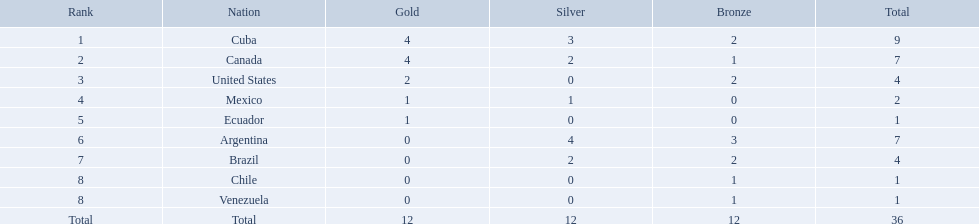What countries participated? Cuba, 4, 3, 2, Canada, 4, 2, 1, United States, 2, 0, 2, Mexico, 1, 1, 0, Ecuador, 1, 0, 0, Argentina, 0, 4, 3, Brazil, 0, 2, 2, Chile, 0, 0, 1, Venezuela, 0, 0, 1. What countries won 1 gold Mexico, 1, 1, 0, Ecuador, 1, 0, 0. What country above also won no silver? Ecuador. Which countries won medals at the 2011 pan american games for the canoeing event? Cuba, Canada, United States, Mexico, Ecuador, Argentina, Brazil, Chile, Venezuela. Which of these countries won bronze medals? Cuba, Canada, United States, Argentina, Brazil, Chile, Venezuela. Of these countries, which won the most bronze medals? Argentina. What were all of the countries participating in canoeing at the 2011 pan american games? Cuba, Canada, United States, Mexico, Ecuador, Argentina, Brazil, Chile, Venezuela, Total. Among them, which had a numerical ranking? Cuba, Canada, United States, Mexico, Ecuador, Argentina, Brazil, Chile, Venezuela. From those, which had the most bronze medals? Argentina. Which nations have secured gold medals? Cuba, Canada, United States, Mexico, Ecuador. Of these nations, which ones have never achieved silver or bronze medals? United States, Ecuador. Of the two countries mentioned earlier, which one has solely won a gold medal? Ecuador. Which nations have garnered gold medals? Cuba, Canada, United States, Mexico, Ecuador. Of these nations, which ones have never earned silver or bronze medals? United States, Ecuador. Of the two countries mentioned before, which one has only won a gold medal? Ecuador. Which national teams earned gold medals? Cuba, Canada, United States, Mexico, Ecuador. How many medals did each national team collect? Cuba, 9, Canada, 7, United States, 4, Mexico, 2, Ecuador, 1. Which national team only captured a gold medal? Ecuador. What nations were involved? Cuba, Canada, United States, Mexico, Ecuador, Argentina, Brazil, Chile, Venezuela. What nations claimed gold? Cuba, Canada, United States, Mexico, Ecuador. What nations failed to get silver? United States, Ecuador, Chile, Venezuela. Among the stated countries, which nation won gold? United States. Can you give me this table as a dict? {'header': ['Rank', 'Nation', 'Gold', 'Silver', 'Bronze', 'Total'], 'rows': [['1', 'Cuba', '4', '3', '2', '9'], ['2', 'Canada', '4', '2', '1', '7'], ['3', 'United States', '2', '0', '2', '4'], ['4', 'Mexico', '1', '1', '0', '2'], ['5', 'Ecuador', '1', '0', '0', '1'], ['6', 'Argentina', '0', '4', '3', '7'], ['7', 'Brazil', '0', '2', '2', '4'], ['8', 'Chile', '0', '0', '1', '1'], ['8', 'Venezuela', '0', '0', '1', '1'], ['Total', 'Total', '12', '12', '12', '36']]} What were the counts of bronze medals gained by the countries? 2, 1, 2, 0, 0, 3, 2, 1, 1. Which is the maximum? 3. Which nation had this total? Argentina. In which nations have gold medals been awarded? Cuba, Canada, United States, Mexico, Ecuador. Among them, which have not received silver or bronze medals? United States, Ecuador. Out of the previously mentioned countries, which one has exclusively achieved a gold medal? Ecuador. In which countries have gold medals been secured? Cuba, Canada, United States, Mexico, Ecuador. From these nations, which ones have never achieved silver or bronze medals? United States, Ecuador. Of the two countries mentioned earlier, which one has only claimed a gold medal? Ecuador. Would you mind parsing the complete table? {'header': ['Rank', 'Nation', 'Gold', 'Silver', 'Bronze', 'Total'], 'rows': [['1', 'Cuba', '4', '3', '2', '9'], ['2', 'Canada', '4', '2', '1', '7'], ['3', 'United States', '2', '0', '2', '4'], ['4', 'Mexico', '1', '1', '0', '2'], ['5', 'Ecuador', '1', '0', '0', '1'], ['6', 'Argentina', '0', '4', '3', '7'], ['7', 'Brazil', '0', '2', '2', '4'], ['8', 'Chile', '0', '0', '1', '1'], ['8', 'Venezuela', '0', '0', '1', '1'], ['Total', 'Total', '12', '12', '12', '36']]} Which countries were involved? Cuba, Canada, United States, Mexico, Ecuador, Argentina, Brazil, Chile, Venezuela. Which countries claimed gold? Cuba, Canada, United States, Mexico, Ecuador. Help me parse the entirety of this table. {'header': ['Rank', 'Nation', 'Gold', 'Silver', 'Bronze', 'Total'], 'rows': [['1', 'Cuba', '4', '3', '2', '9'], ['2', 'Canada', '4', '2', '1', '7'], ['3', 'United States', '2', '0', '2', '4'], ['4', 'Mexico', '1', '1', '0', '2'], ['5', 'Ecuador', '1', '0', '0', '1'], ['6', 'Argentina', '0', '4', '3', '7'], ['7', 'Brazil', '0', '2', '2', '4'], ['8', 'Chile', '0', '0', '1', '1'], ['8', 'Venezuela', '0', '0', '1', '1'], ['Total', 'Total', '12', '12', '12', '36']]} Which countries missed out on silver? United States, Ecuador, Chile, Venezuela. From the listed countries, which one earned gold? United States. Which countries participated? Cuba, Canada, United States, Mexico, Ecuador, Argentina, Brazil, Chile, Venezuela. Which countries captured gold? Cuba, Canada, United States, Mexico, Ecuador. Which countries did not receive silver? United States, Ecuador, Chile, Venezuela. Of the aforementioned countries, which country won gold? United States. In the 2011 pan american games, which nations were awarded medals for canoeing? Cuba, Canada, United States, Mexico, Ecuador, Argentina, Brazil, Chile, Venezuela. Among them, who received bronze medals? Cuba, Canada, United States, Argentina, Brazil, Chile, Venezuela. Which country secured the highest number of bronze medals? Argentina. 